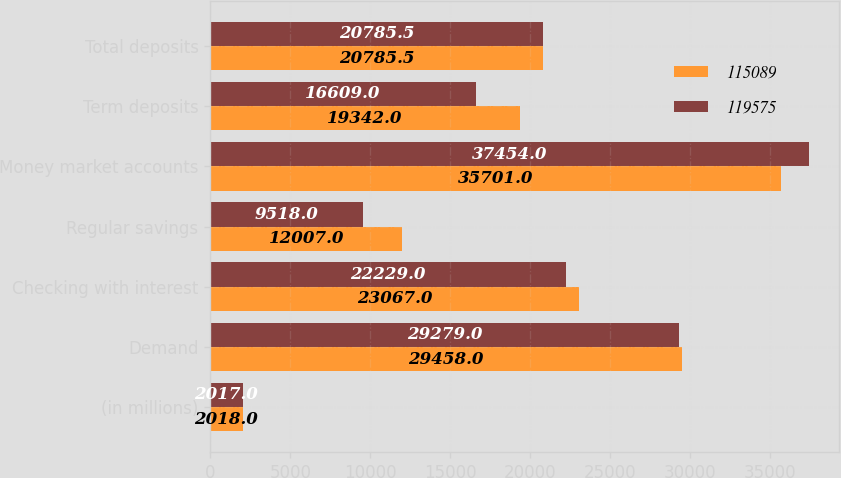Convert chart. <chart><loc_0><loc_0><loc_500><loc_500><stacked_bar_chart><ecel><fcel>(in millions)<fcel>Demand<fcel>Checking with interest<fcel>Regular savings<fcel>Money market accounts<fcel>Term deposits<fcel>Total deposits<nl><fcel>115089<fcel>2018<fcel>29458<fcel>23067<fcel>12007<fcel>35701<fcel>19342<fcel>20785.5<nl><fcel>119575<fcel>2017<fcel>29279<fcel>22229<fcel>9518<fcel>37454<fcel>16609<fcel>20785.5<nl></chart> 